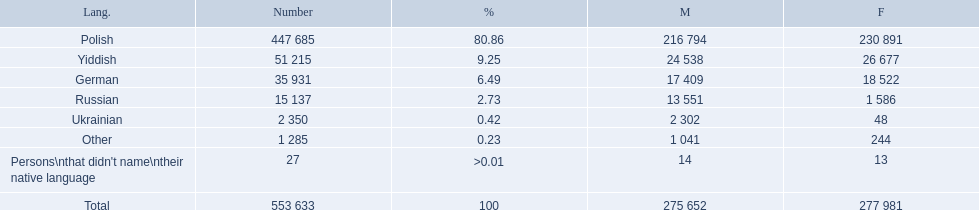What languages are there? Polish, Yiddish, German, Russian, Ukrainian. What numbers speak these languages? 447 685, 51 215, 35 931, 15 137, 2 350. What numbers are not listed as speaking these languages? 1 285, 27. What are the totals of these speakers? 553 633. 